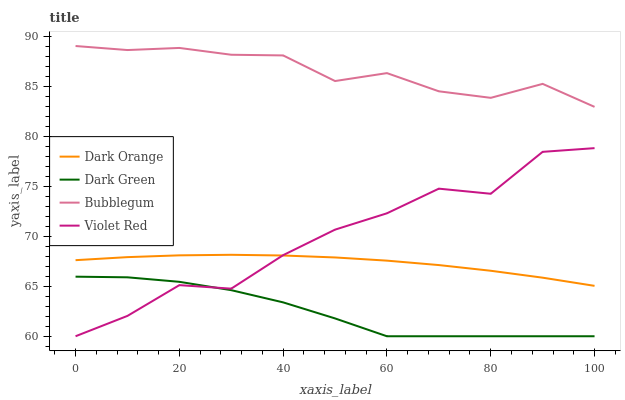Does Dark Green have the minimum area under the curve?
Answer yes or no. Yes. Does Bubblegum have the maximum area under the curve?
Answer yes or no. Yes. Does Violet Red have the minimum area under the curve?
Answer yes or no. No. Does Violet Red have the maximum area under the curve?
Answer yes or no. No. Is Dark Orange the smoothest?
Answer yes or no. Yes. Is Violet Red the roughest?
Answer yes or no. Yes. Is Bubblegum the smoothest?
Answer yes or no. No. Is Bubblegum the roughest?
Answer yes or no. No. Does Violet Red have the lowest value?
Answer yes or no. Yes. Does Bubblegum have the lowest value?
Answer yes or no. No. Does Bubblegum have the highest value?
Answer yes or no. Yes. Does Violet Red have the highest value?
Answer yes or no. No. Is Violet Red less than Bubblegum?
Answer yes or no. Yes. Is Bubblegum greater than Violet Red?
Answer yes or no. Yes. Does Dark Green intersect Violet Red?
Answer yes or no. Yes. Is Dark Green less than Violet Red?
Answer yes or no. No. Is Dark Green greater than Violet Red?
Answer yes or no. No. Does Violet Red intersect Bubblegum?
Answer yes or no. No. 